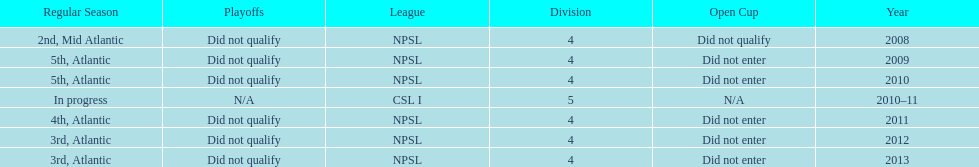How did they place the year after they were 4th in the regular season? 3rd. 